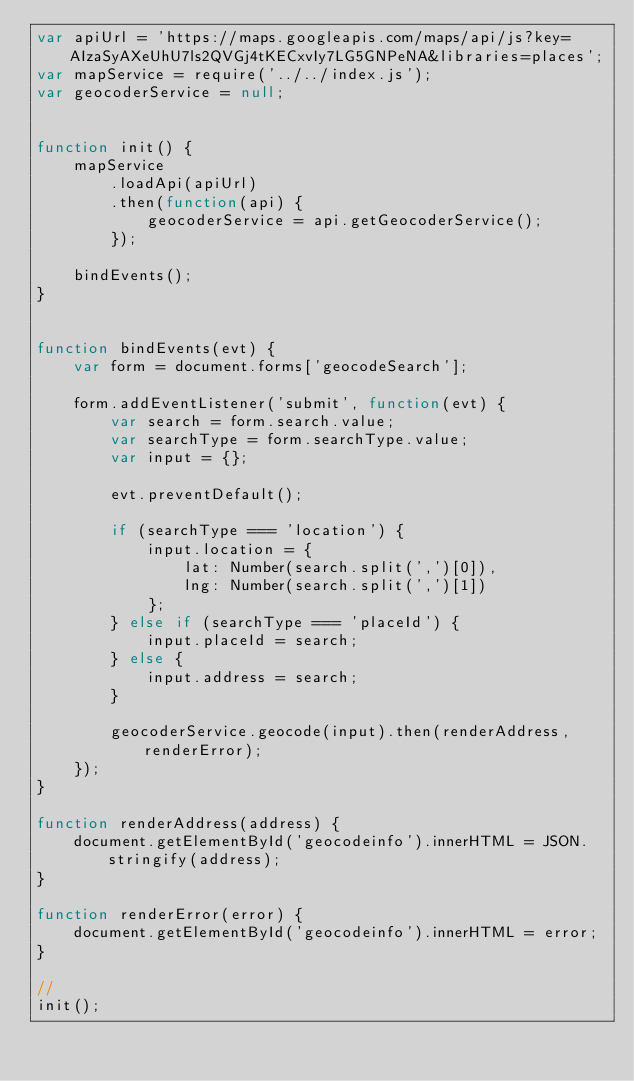<code> <loc_0><loc_0><loc_500><loc_500><_JavaScript_>var apiUrl = 'https://maps.googleapis.com/maps/api/js?key=AIzaSyAXeUhU7ls2QVGj4tKECxvIy7LG5GNPeNA&libraries=places';
var mapService = require('../../index.js');
var geocoderService = null;


function init() {        
    mapService
        .loadApi(apiUrl)
        .then(function(api) {
            geocoderService = api.getGeocoderService();
        });
    
    bindEvents();
}


function bindEvents(evt) {
    var form = document.forms['geocodeSearch'];

    form.addEventListener('submit', function(evt) {
        var search = form.search.value;
        var searchType = form.searchType.value;
        var input = {};
        
        evt.preventDefault();

        if (searchType === 'location') {
            input.location = {
                lat: Number(search.split(',')[0]),
                lng: Number(search.split(',')[1])
            };
        } else if (searchType === 'placeId') {
            input.placeId = search;
        } else {
            input.address = search;
        }

        geocoderService.geocode(input).then(renderAddress, renderError);
    });
}

function renderAddress(address) {
    document.getElementById('geocodeinfo').innerHTML = JSON.stringify(address);
}

function renderError(error) {
    document.getElementById('geocodeinfo').innerHTML = error;
}

//
init();
</code> 